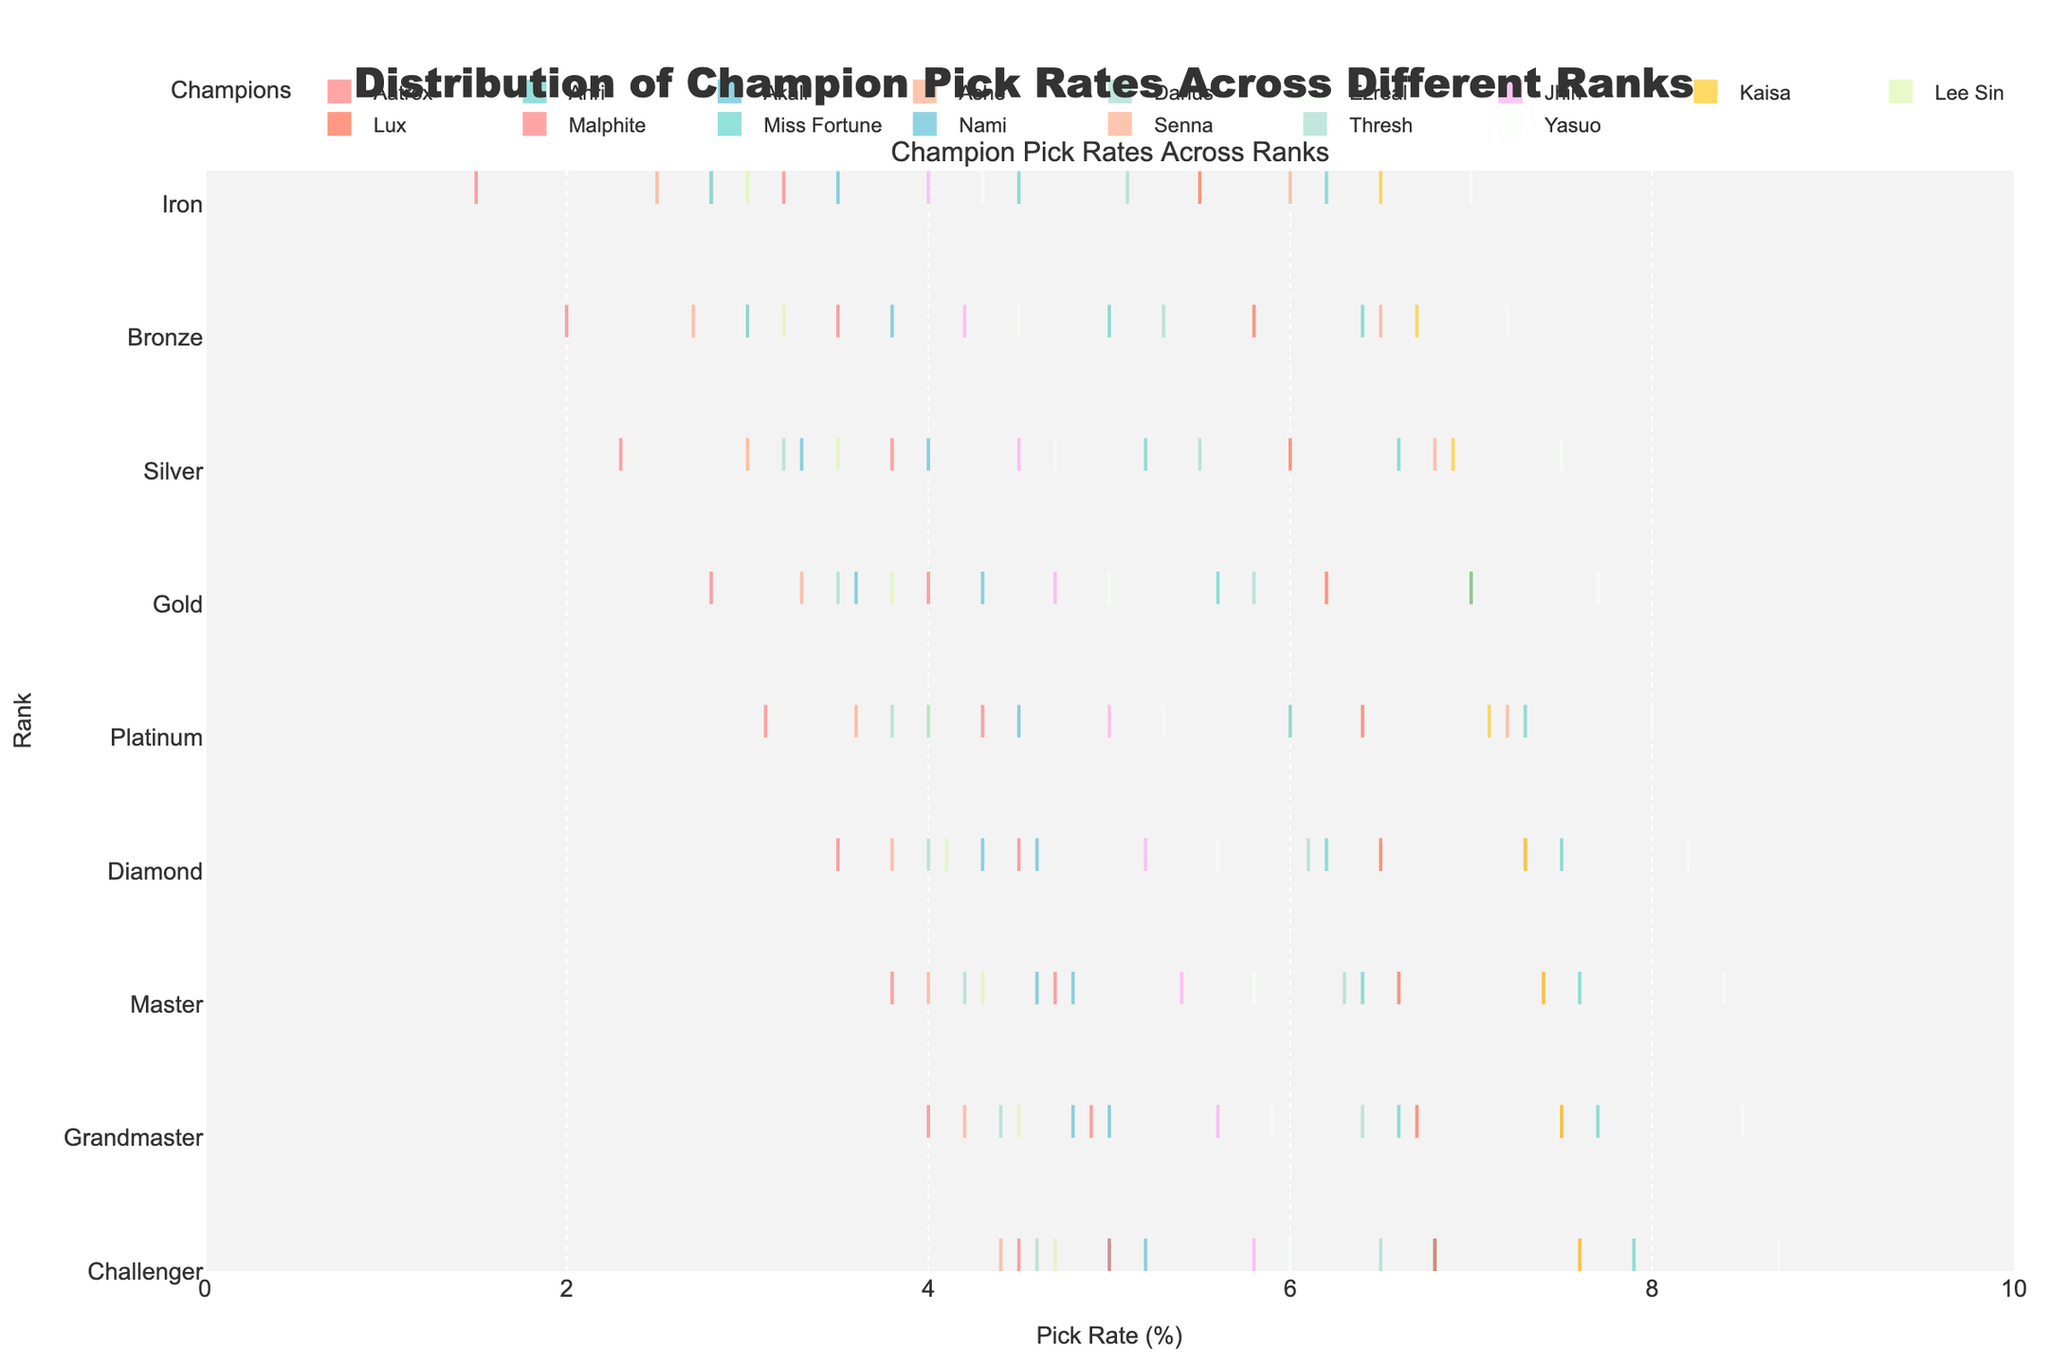What is the title of the figure? The title is typically displayed at the top of the figure in a larger font size. The title here is clearly mentioned.
Answer: Distribution of Champion Pick Rates Across Different Ranks Which champion has the highest pick rate in the Challenger rank? By examining the rightmost end of the violin plots oriented horizontally, we can identify the champion with the highest end point in the Challenger rank.
Answer: Yasuo Which champion has the lowest pick rate in the Iron rank? By examining the leftmost end of the violin plots in the Iron rank, we can identify the champion with the lowest end point in the Iron rank.
Answer: Aatrox What is the range of pick rates for Miss Fortune from Iron to Challenger? To find the range, take the difference between the maximum and minimum pick rates of Miss Fortune from Iron to Challenger. Here, it is from 6.2% in Iron to 7.9% in Challenger. Range = 7.9% - 6.2% = 1.7%.
Answer: 1.7% Compare the pick rates of Lux and Ahri in the Platinum rank. Which has a higher pick rate? Find the pick rates for both Lux and Ahri in the Platinum rank and compare them. Ahri has 6.2% and Lux has 6.5%.
Answer: Lux How do the pick rates of Darius differ across the different ranks? To answer this, note the pick rates for Darius across all ranks and describe how they increase or decrease. Darius: 5.1 (Iron), 5.3 (Bronze), 5.5 (Silver), 5.8 (Gold), 6.0 (Platinum), 6.1 (Diamond), 6.3 (Master), 6.4 (Grandmaster), 6.5 (Challenger).
Answer: Increasing trend from Iron to Challenger What's the average pick rate of Ashe across all ranks? Calculate the average pick rate by summing the pick rates of Ashe across all ranks and dividing by the number of ranks. Ashe: (6.0 + 6.5 + 6.8 + 7.0 + 7.2 + 7.3 + 7.4 + 7.5 + 7.6) / 9 = 7.033%.
Answer: 7.033% Which champion shows the least variability in pick rates across ranks, and what indicates this? Identify the champion whose pick rates are closest together across all ranks, implying the narrowest horizontal spread.
Answer: Kaisa Between Akali and Nami, which champion has a more consistent increase in pick rate across ranks? Examine the progression of pick rates for both champions; the one with less fluctuation and a steady increase is more consistent. Akali: (2.8, 3.0, 3.3, 3.6, 4.0, 4.3, 4.6, 4.8, 5.0), Nami: (3.5, 3.8, 4.0, 4.3, 4.5, 4.6, 4.8, 5.0, 5.2). Akali has a steady increase.
Answer: Akali Compare the variability in pick rates between Kaisa and Miss Fortune across ranks. Which one has wider variability? Assess the spread of the horizontal violin plots for both champions across ranks. The champion with a wider spread indicates higher variability.
Answer: Miss Fortune 